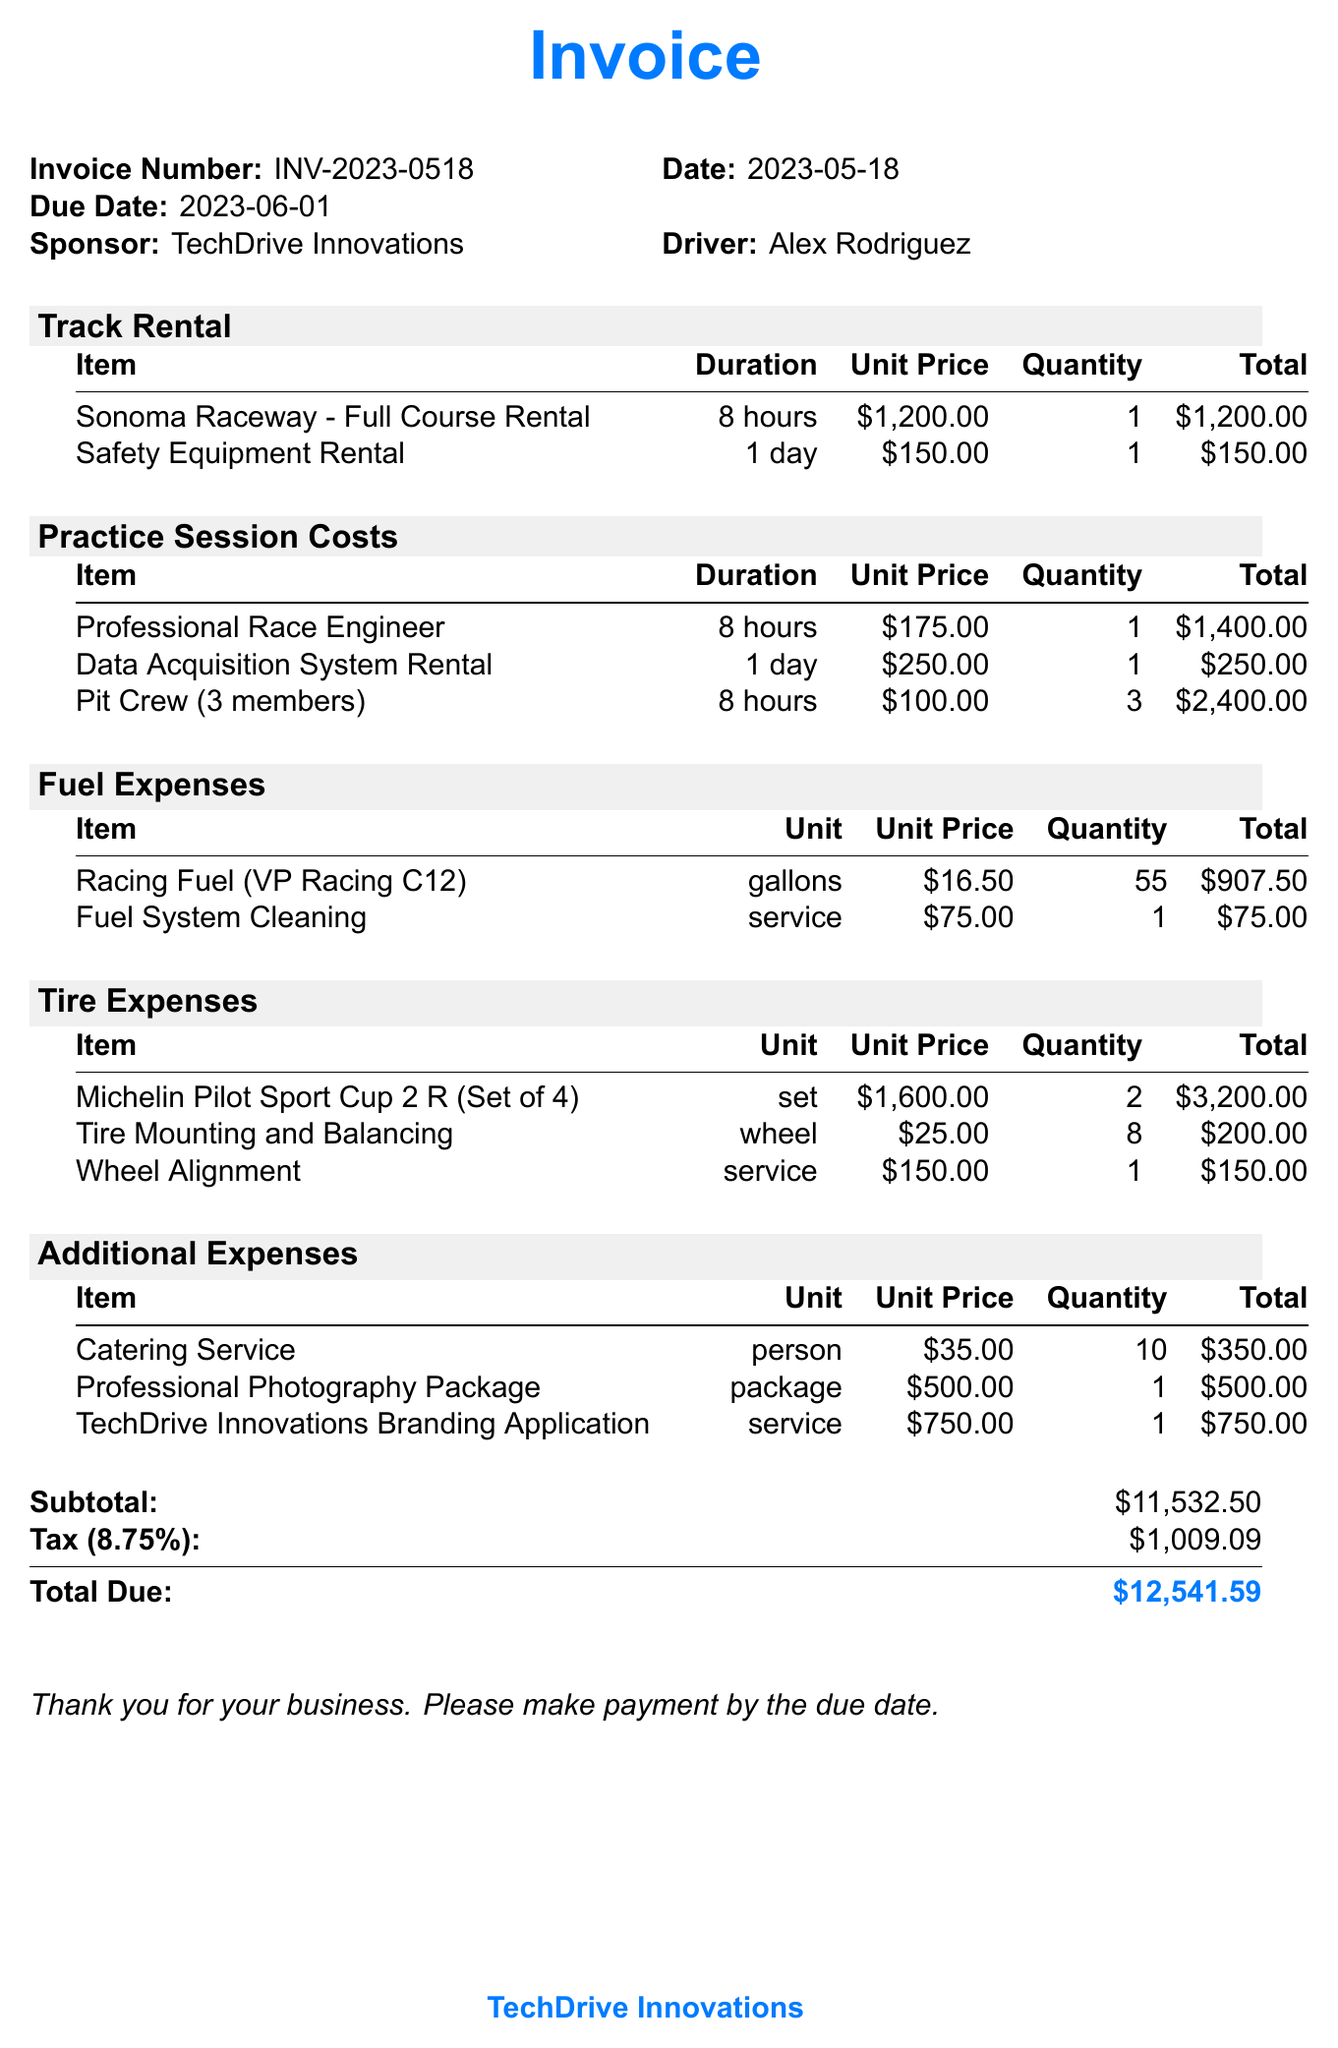What is the invoice number? The invoice number is clearly stated at the top of the document as INV-2023-0518.
Answer: INV-2023-0518 What is the date of the invoice? The date of the invoice is mentioned alongside the invoice number and is specified as 2023-05-18.
Answer: 2023-05-18 How much does the Sonoma Raceway rental cost? The cost of the Sonoma Raceway rental is specified in the track rental section as $1,200.00.
Answer: $1,200.00 What is the total amount due? The total amount due is the final sum calculated at the bottom of the document, which is $12,541.59.
Answer: $12,541.59 How many gallons of racing fuel were purchased? The document states that 55 gallons of racing fuel were purchased, listed in the fuel expenses section.
Answer: 55 What is the duration of the professional race engineer's service? The duration for the professional race engineer's service is mentioned as 8 hours in the practice session costs.
Answer: 8 hours What is the tax rate applied to the total? The tax rate is clearly indicated in the subtotal section as 8.75%.
Answer: 8.75% How many members were in the pit crew? The pit crew consists of 3 members as mentioned in the practice session costs section.
Answer: 3 members What is the total cost of tire mounting and balancing? The total cost for tire mounting and balancing is given as $200.00 in the tire expenses section.
Answer: $200.00 